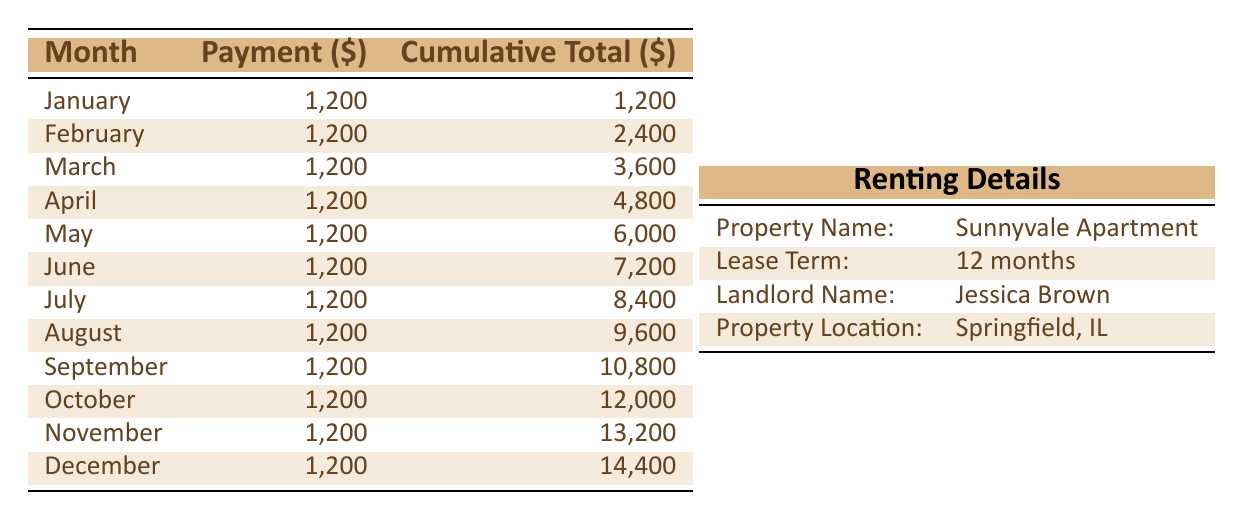What is the payment amount for each month? Each month, the table lists a payment amount of 1,200 dollars. This is consistent across all months from January to December.
Answer: 1,200 How much total rent will be paid by the end of the year (December)? The cumulative total for December is given as 14,400 dollars. This amount indicates the total rent paid throughout the year.
Answer: 14,400 In which month is the cumulative total at 7,200 dollars? Referring to the cumulative total column, the value of 7,200 dollars occurs in June. The table shows the cumulative totals for each month, and June corresponds to that figure.
Answer: June What is the difference in cumulative totals between May and November? The cumulative total in May is 6,000 dollars and in November is 13,200 dollars. The difference is calculated as 13,200 - 6,000 = 7,200 dollars.
Answer: 7,200 Is the payment for October the same as the payment for January? The payment for October is listed as 1,200 dollars, which is exactly the same as the payment for January (also 1,200 dollars). Therefore, the statement is true.
Answer: Yes If I total the payments from January to March, what will that amount be? Adding the payments for January, February, and March gives: 1,200 + 1,200 + 1,200 = 3,600 dollars. This is derived from the payment amounts listed for these months.
Answer: 3,600 How many months have a cumulative total greater than 10,000 dollars? Referring to the cumulative totals, the months with values greater than 10,000 dollars are October, November, and December. Observing the cumulative totals for these months confirms there are three of them.
Answer: 3 In what month does the cumulative total exceed 9,000 dollars for the first time? The cumulative total first exceeds 9,000 dollars in the month of September, as the cumulative total is recorded at 10,800 dollars during that month.
Answer: September What is the average monthly payment amount over the year? Since the monthly payment is constant at 1,200 dollars over 12 months, the average payment is simply 1,200 dollars. As there are no variations in the payments made each month, this remains the same.
Answer: 1,200 